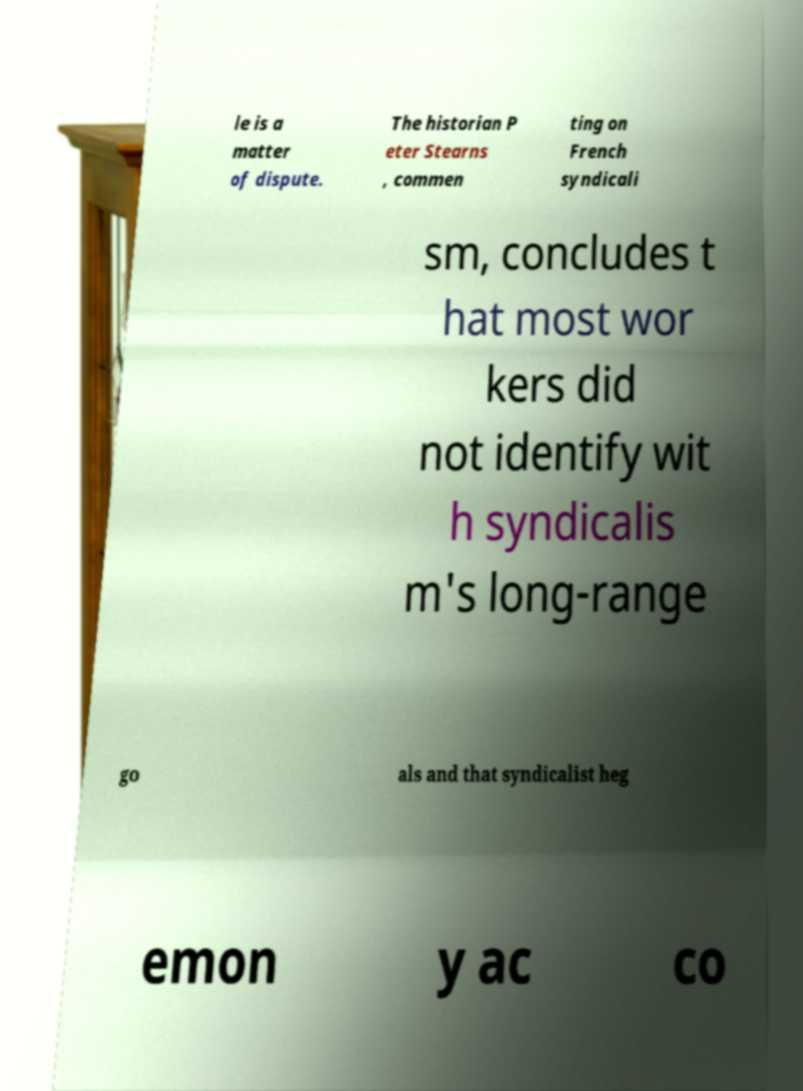For documentation purposes, I need the text within this image transcribed. Could you provide that? le is a matter of dispute. The historian P eter Stearns , commen ting on French syndicali sm, concludes t hat most wor kers did not identify wit h syndicalis m's long-range go als and that syndicalist heg emon y ac co 